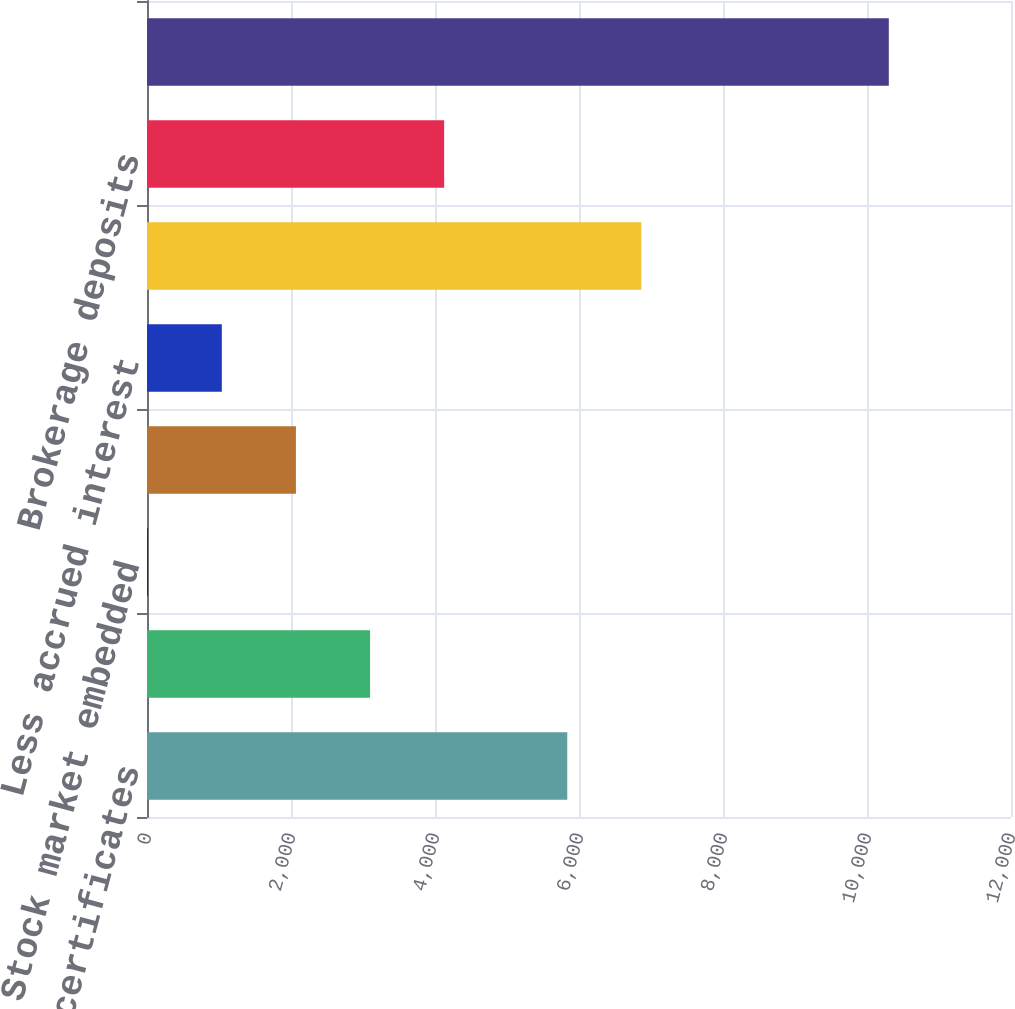<chart> <loc_0><loc_0><loc_500><loc_500><bar_chart><fcel>Fixed rate certificates<fcel>Stock market certificates<fcel>Stock market embedded<fcel>Other<fcel>Less accrued interest<fcel>Total investment certificate<fcel>Brokerage deposits<fcel>Total<nl><fcel>5837<fcel>3097.9<fcel>10<fcel>2068.6<fcel>1039.3<fcel>6866.3<fcel>4127.2<fcel>10303<nl></chart> 